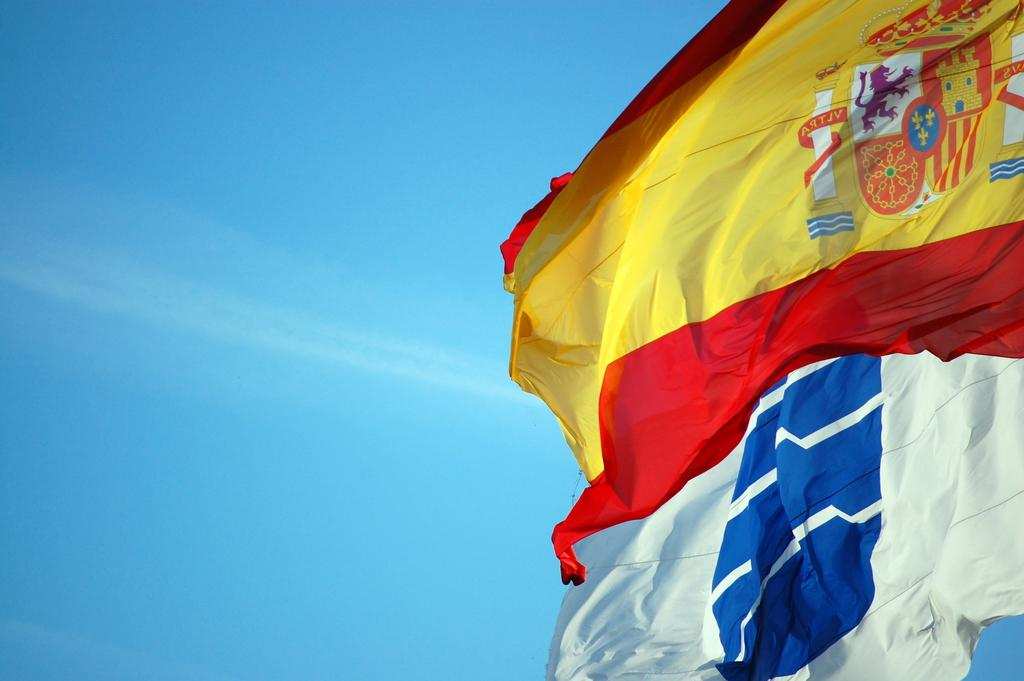How many flags are present in the image? There are two flags in the image. What is unique about one of the flags? One of the flags has logos on it. What can be seen in the background of the image? The sky is visible in the background of the image. What type of pleasure can be seen in the image? There is no indication of pleasure in the image; it features two flags and a visible sky. 